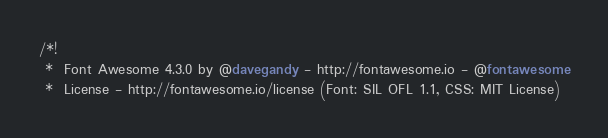<code> <loc_0><loc_0><loc_500><loc_500><_CSS_>/*!
 *  Font Awesome 4.3.0 by @davegandy - http://fontawesome.io - @fontawesome
 *  License - http://fontawesome.io/license (Font: SIL OFL 1.1, CSS: MIT License)</code> 